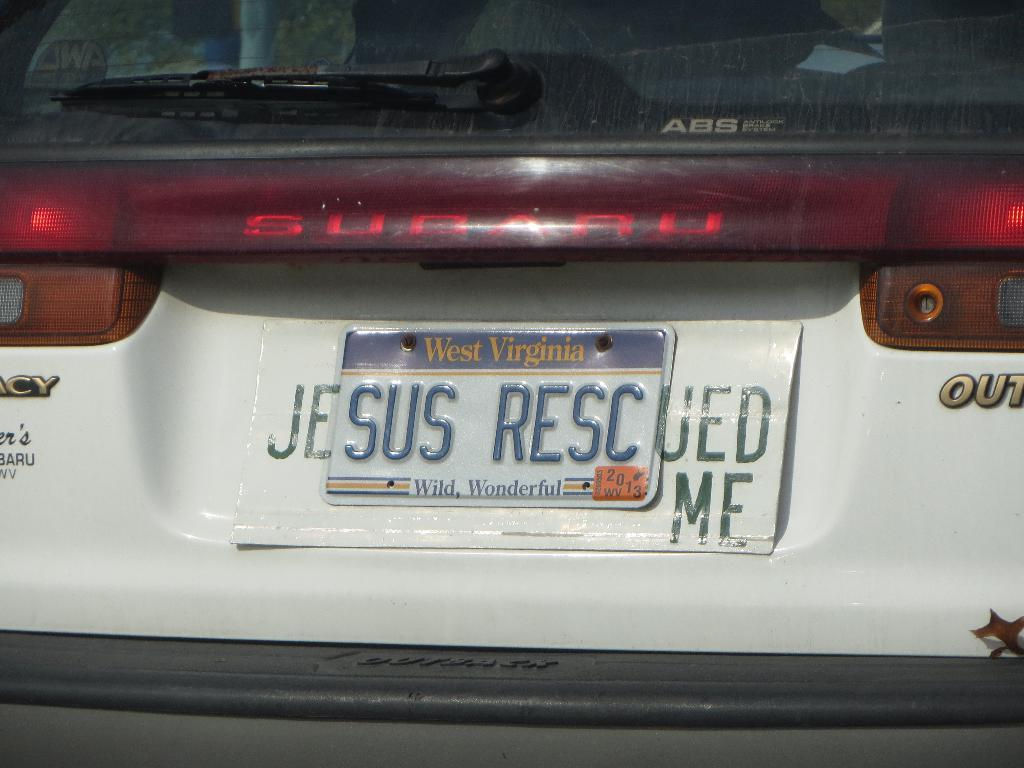Provide a one-sentence caption for the provided image. Car owner gets creative by adding Je and UED ME to their SUS RESC licence plate. 